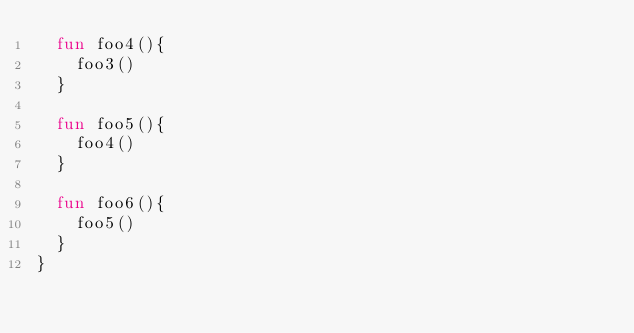Convert code to text. <code><loc_0><loc_0><loc_500><loc_500><_Kotlin_>  fun foo4(){
    foo3()
  }

  fun foo5(){
    foo4()
  }

  fun foo6(){
    foo5()
  }
}</code> 